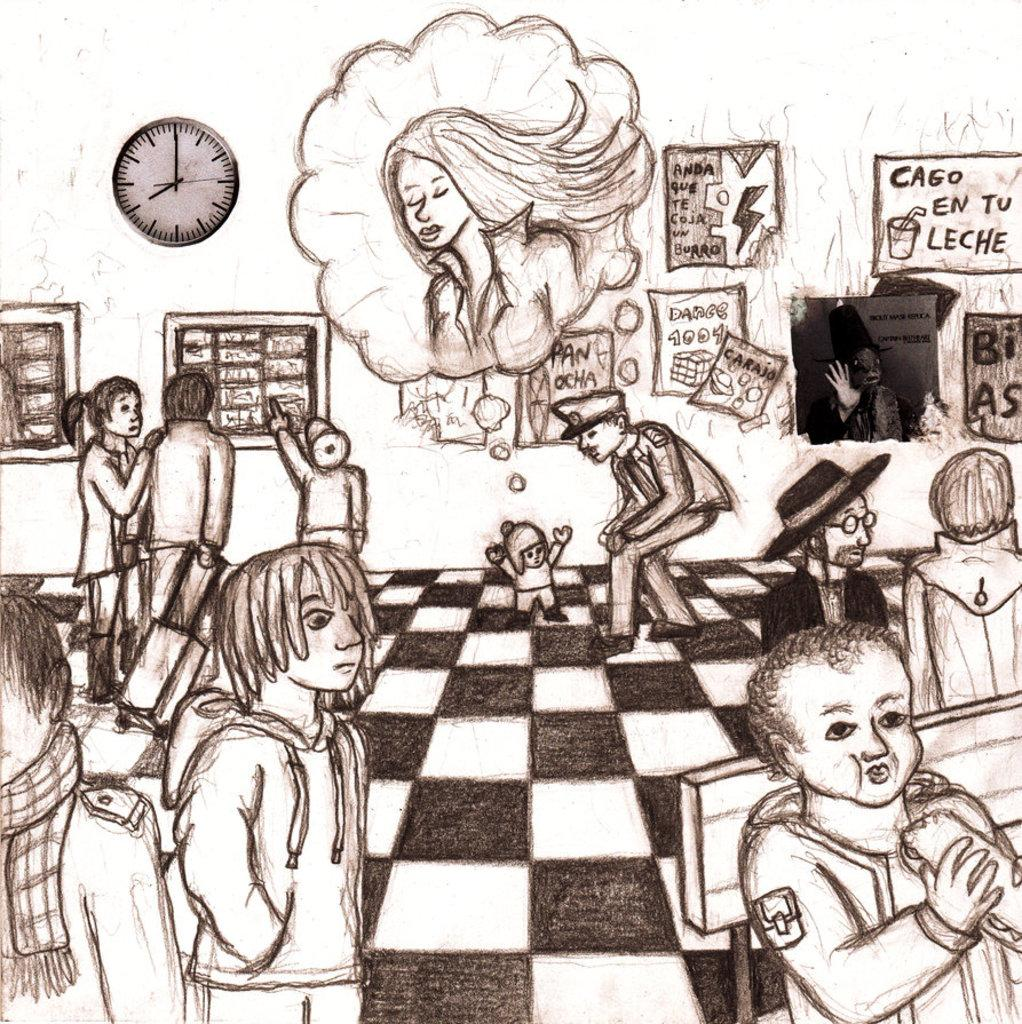<image>
Offer a succinct explanation of the picture presented. A black and white drawing with the words Caso en tu leche in the upper corner. 